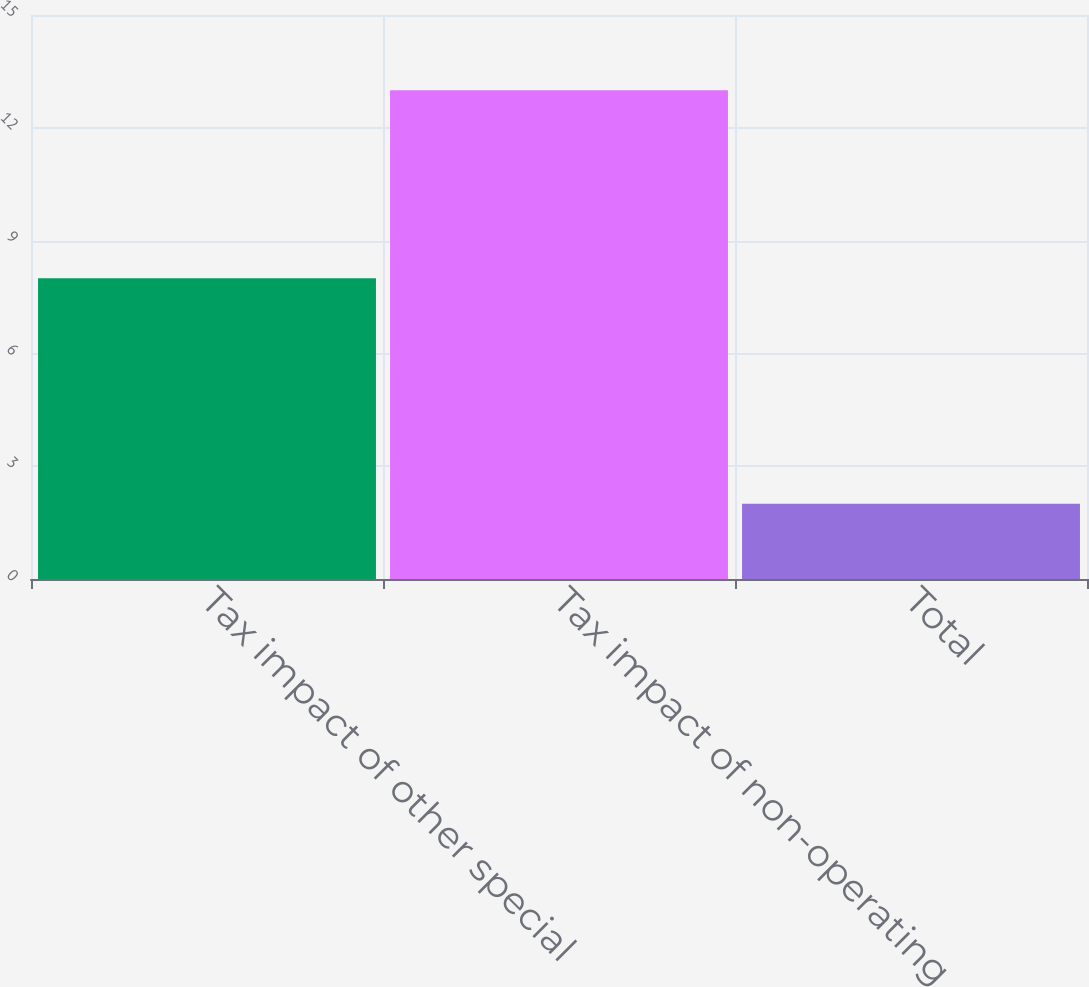Convert chart. <chart><loc_0><loc_0><loc_500><loc_500><bar_chart><fcel>Tax impact of other special<fcel>Tax impact of non-operating<fcel>Total<nl><fcel>8<fcel>13<fcel>2<nl></chart> 